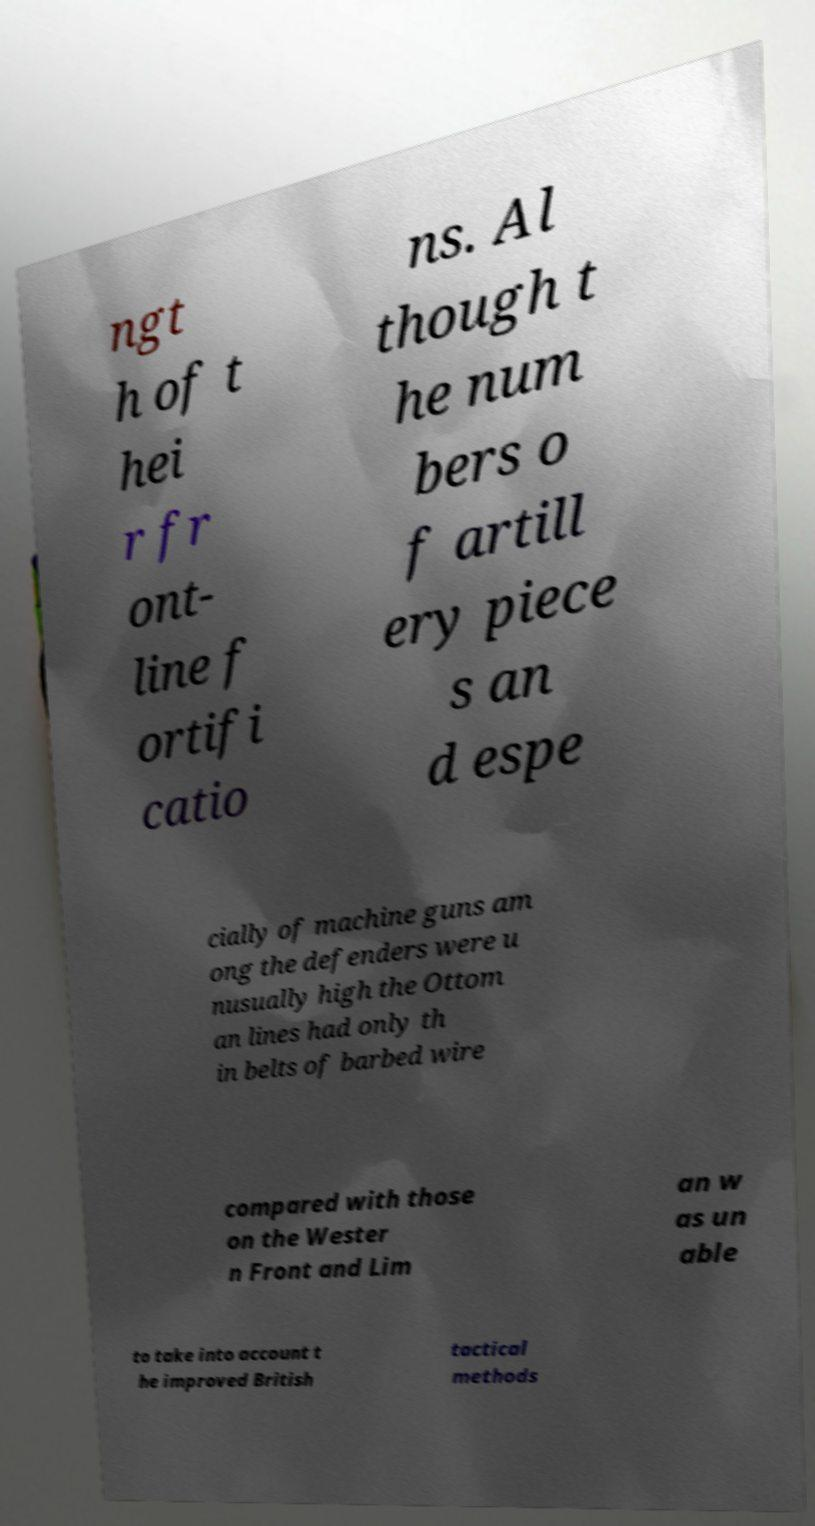I need the written content from this picture converted into text. Can you do that? ngt h of t hei r fr ont- line f ortifi catio ns. Al though t he num bers o f artill ery piece s an d espe cially of machine guns am ong the defenders were u nusually high the Ottom an lines had only th in belts of barbed wire compared with those on the Wester n Front and Lim an w as un able to take into account t he improved British tactical methods 